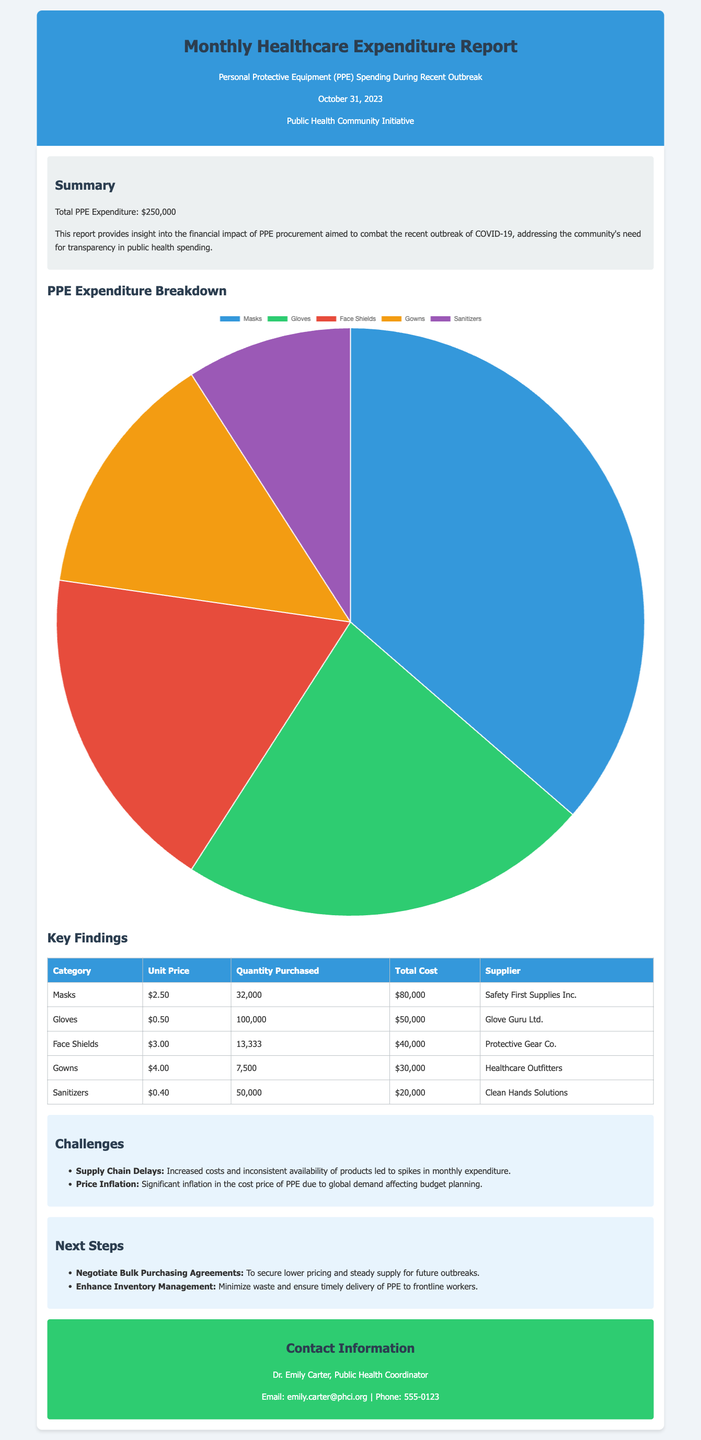What is the total PPE expenditure? The total PPE expenditure is mentioned in the summary section of the document.
Answer: $250,000 How many masks were purchased? The table provides the quantity purchased for each category including masks.
Answer: 32,000 What is the unit price of gloves? The unit price for gloves is listed in the PPE Expenditure Breakdown table.
Answer: $0.50 Which supplier provided face shields? The supplier for face shields is indicated in the corresponding row of the table.
Answer: Protective Gear Co What are the challenges faced according to the report? The report lists two major challenges in a specific section dedicated to challenges.
Answer: Supply Chain Delays, Price Inflation What is one next step proposed in the report? The report includes several next steps for future planning in the relevant section.
Answer: Negotiate Bulk Purchasing Agreements What is the date of the report? The date of the report can be found in the header section.
Answer: October 31, 2023 What is the total cost of gowns? The total cost for gowns is specified in the breakdown table among other items.
Answer: $30,000 What is the background color of the header? The header’s background color is described in the style section of the document.
Answer: #3498db 